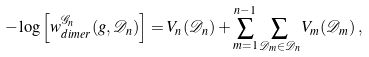Convert formula to latex. <formula><loc_0><loc_0><loc_500><loc_500>- \log \left [ w _ { d i m e r } ^ { { \mathcal { G } } _ { n } } ( g , { \mathcal { D } } _ { n } ) \right ] = V _ { n } ( { \mathcal { D } } _ { n } ) + \sum _ { m = 1 } ^ { n - 1 } \sum _ { { \mathcal { D } } _ { m } \in { \mathcal { D } } _ { n } } V _ { m } ( { \mathcal { D } } _ { m } ) \, ,</formula> 